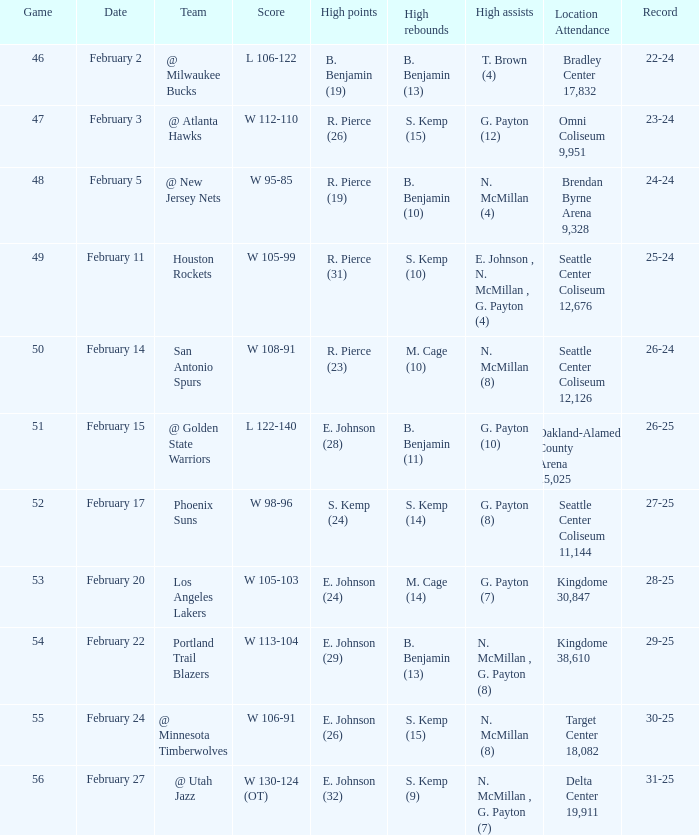When was the event conducted at the venue delta center 19,911? February 27. 